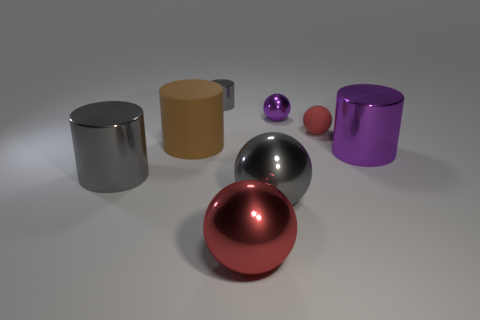There is a cylinder that is behind the purple metallic ball; is its size the same as the large brown rubber cylinder?
Your answer should be compact. No. Are there any other things that have the same shape as the small gray object?
Offer a very short reply. Yes. There is a object that is behind the tiny purple ball; is its color the same as the metal thing to the left of the small gray metallic object?
Ensure brevity in your answer.  Yes. There is a large ball that is the same color as the tiny metallic cylinder; what is its material?
Ensure brevity in your answer.  Metal. Is the shape of the large red metal thing the same as the purple shiny object left of the large purple shiny thing?
Keep it short and to the point. Yes. Is there a large object of the same color as the small rubber ball?
Give a very brief answer. Yes. Is there another gray object that has the same shape as the big matte thing?
Provide a short and direct response. Yes. How many things are large shiny things on the left side of the big gray metal sphere or tiny cyan rubber spheres?
Provide a short and direct response. 2. Is the number of tiny gray cylinders behind the small metallic cylinder less than the number of cylinders that are in front of the small red matte sphere?
Make the answer very short. Yes. There is a large red sphere; are there any big shiny cylinders right of it?
Keep it short and to the point. Yes. 